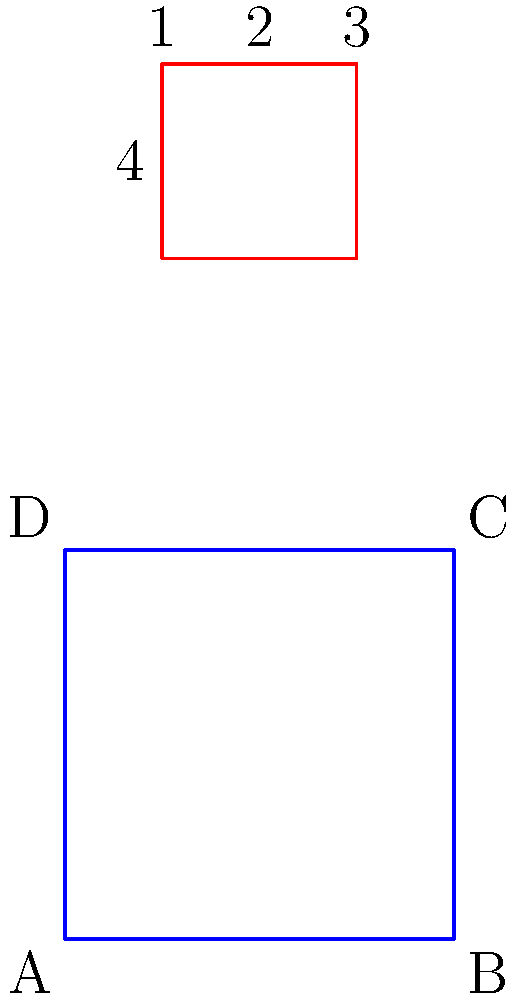Imagine you're designing a new vinyl album cover. The image shows a 3D cube representing the album case and its flattened version above. If you were to fold the flattened design into the 3D cube, which numbered face would be opposite to face C? To solve this problem, let's follow these steps:

1. Identify face C on the 3D cube. It's the top-right face of the cube.

2. Analyze the flattened design:
   - Face 5 is in the center, which will be the front face of the cube.
   - Faces 1, 2, and 3 form the top row of the flattened design.
   - Faces 4 and 6 are on the sides of face 5.

3. Mentally fold the flattened design:
   - Face 5 stays as the front.
   - Face 2 becomes the top of the cube.
   - Face 4 folds to the left side.
   - Face 6 folds to the right side.
   - Face 1 folds to the back.
   - Face 3 folds to the bottom.

4. Identify the opposite faces:
   - Front (5) is opposite to Back (1)
   - Top (2) is opposite to Bottom (3)
   - Left (4) is opposite to Right (6)

5. Since face C is on the right side of the 3D cube, its opposite will be the left side.

6. The left side in the folded cube corresponds to face 4 in the flattened design.

Therefore, face 4 will be opposite to face C when the flattened design is folded into a cube.
Answer: 4 